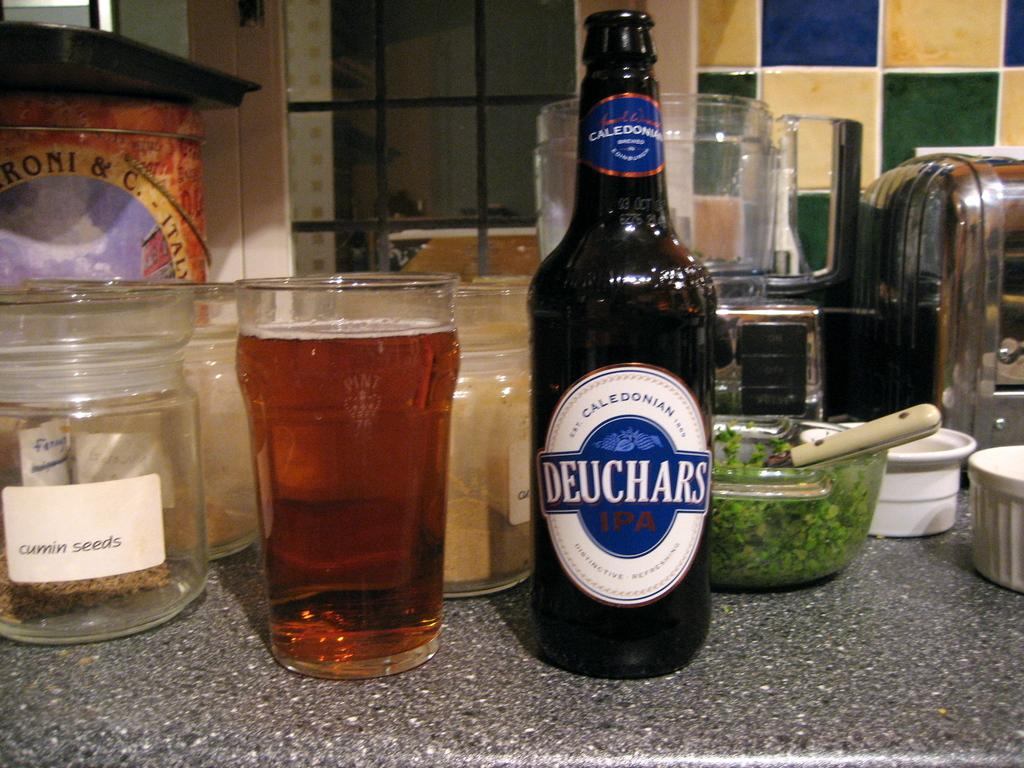Provide a one-sentence caption for the provided image. A Deuchars branded beer poured into a glass. 